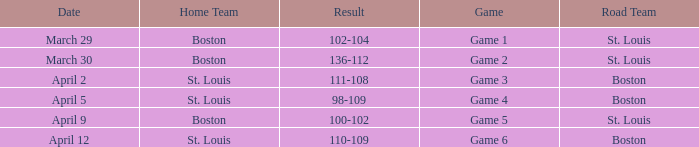What is the Result of Game 3? 111-108. 